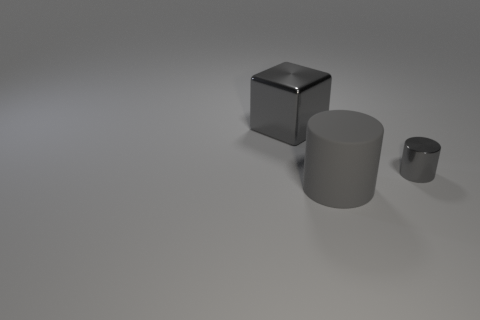There is a rubber cylinder; is its color the same as the shiny thing that is in front of the large cube?
Your response must be concise. Yes. Are there any matte things of the same size as the metal block?
Your answer should be compact. Yes. What is the material of the big object on the left side of the large gray object that is in front of the tiny shiny thing?
Give a very brief answer. Metal. What number of other big objects have the same color as the large rubber object?
Give a very brief answer. 1. The other object that is the same material as the small gray thing is what shape?
Your answer should be very brief. Cube. There is a gray metallic thing behind the tiny cylinder; how big is it?
Keep it short and to the point. Large. Are there an equal number of big things in front of the big metallic thing and small cylinders that are in front of the gray shiny cylinder?
Make the answer very short. No. There is a shiny object on the left side of the cylinder that is in front of the gray metal object in front of the large gray block; what is its color?
Your answer should be compact. Gray. How many big gray objects are both in front of the large metal cube and behind the big gray cylinder?
Offer a very short reply. 0. Is there any other thing that is made of the same material as the big gray cylinder?
Your response must be concise. No. 